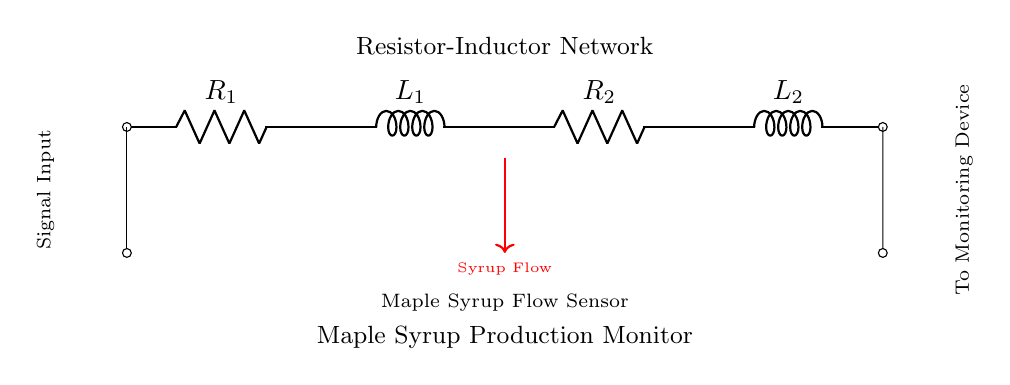What are the components in the circuit? The circuit contains two resistors and two inductors as indicated by the labels R and L on the diagram.
Answer: resistors and inductors What is the direction of the signal flow? The signal flows from the left side, entering through the signal input, and exits to the monitoring device on the right side, as shown by the arrows and labels.
Answer: left to right How many resistors are in the circuit? There are two resistors present in the diagram, labeled as R1 and R2.
Answer: 2 What is term used to refer to the flow sensor in this circuit? The flow sensor is referred to as the "Maple Syrup Flow Sensor," which is indicated in the diagram.
Answer: Maple Syrup Flow Sensor What can we infer about the relationship between the inductors and resistors in this circuit? The inductors and resistors are part of an R-L network where they are connected in series, influencing the overall impedance and trying to smooth out the signal from the syrup flow sensor.
Answer: Series connection affecting impedance What is the purpose of the resistor-inductor network in the context of this diagram? The resistor-inductor network is likely used to filter and condition the signal from the syrup flow sensor to ensure that it is stable and suitable for monitoring.
Answer: Signal conditioning What happens if one inductor fails in this circuit? If one inductor fails, it could disrupt the circuit's inductive properties and alter the signal filtering and responsiveness to changes in syrup flow, potentially leading to inaccurate monitoring.
Answer: Disruption of filtering and response 